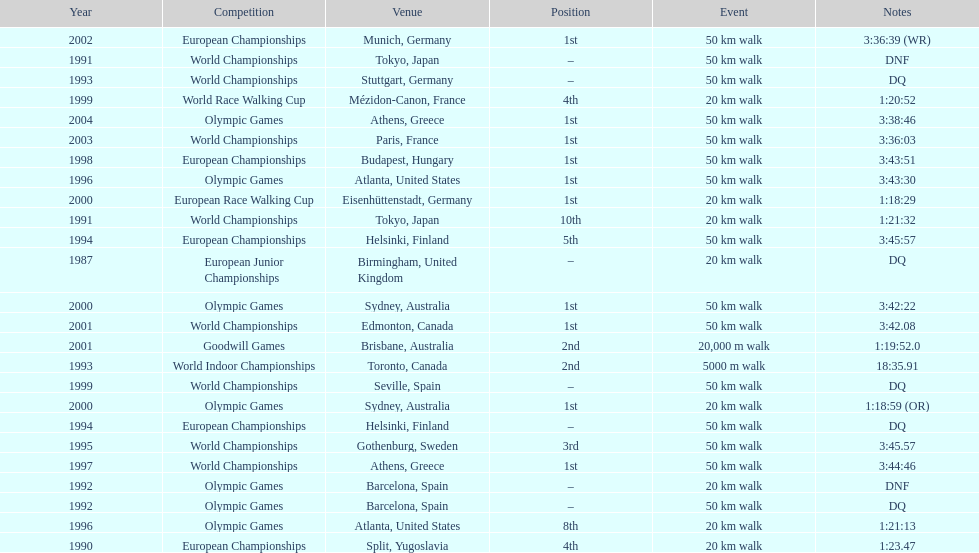How long did it take to walk 50 km in the 2004 olympic games? 3:38:46. 